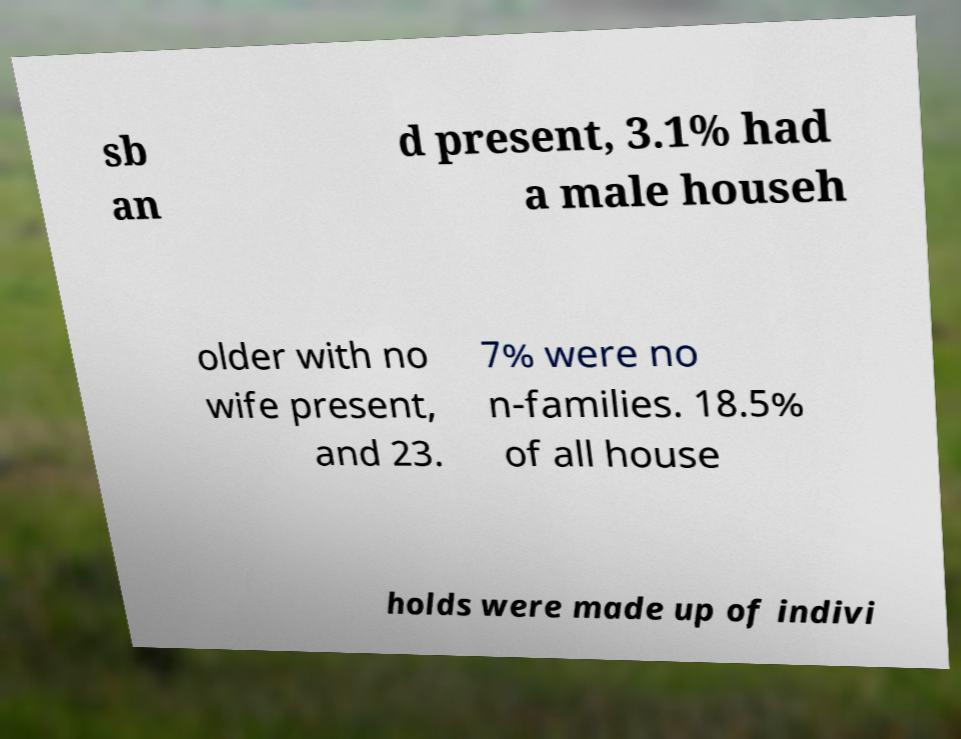What messages or text are displayed in this image? I need them in a readable, typed format. sb an d present, 3.1% had a male househ older with no wife present, and 23. 7% were no n-families. 18.5% of all house holds were made up of indivi 